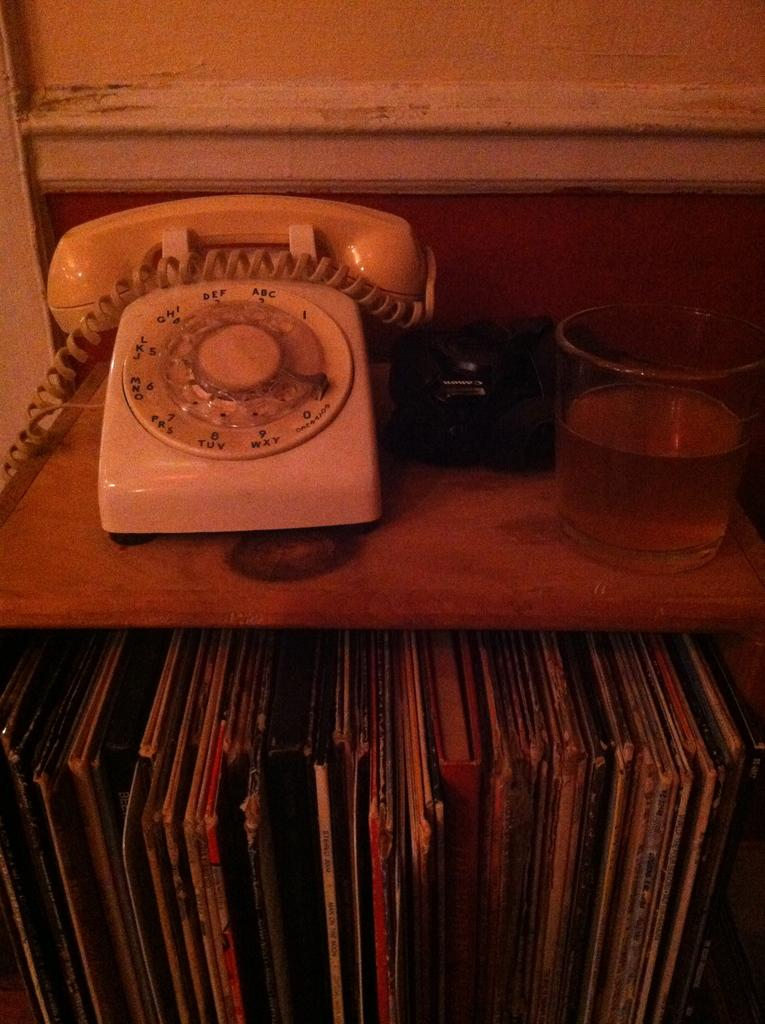<image>
Give a short and clear explanation of the subsequent image. A table that has a telephone rotary dial type with letters of the alphabet on the dial like ABC,DEF, and on while there are Albums on the shelf. 